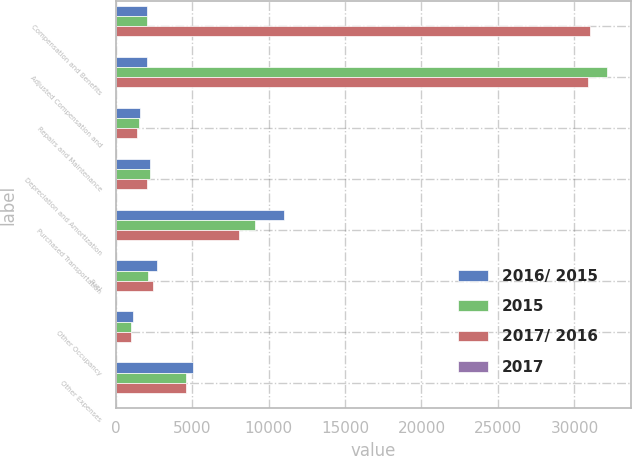Convert chart to OTSL. <chart><loc_0><loc_0><loc_500><loc_500><stacked_bar_chart><ecel><fcel>Compensation and Benefits<fcel>Adjusted Compensation and<fcel>Repairs and Maintenance<fcel>Depreciation and Amortization<fcel>Purchased Transportation<fcel>Fuel<fcel>Other Occupancy<fcel>Other Expenses<nl><fcel>2016/ 2015<fcel>2084<fcel>2084<fcel>1600<fcel>2282<fcel>10989<fcel>2690<fcel>1155<fcel>5039<nl><fcel>2015<fcel>2084<fcel>32119<fcel>1538<fcel>2224<fcel>9129<fcel>2118<fcel>1037<fcel>4623<nl><fcel>2017/ 2016<fcel>31028<fcel>30910<fcel>1400<fcel>2084<fcel>8043<fcel>2482<fcel>1022<fcel>4636<nl><fcel>2017<fcel>0.5<fcel>5.2<fcel>4<fcel>2.6<fcel>20.4<fcel>27<fcel>11.4<fcel>9<nl></chart> 